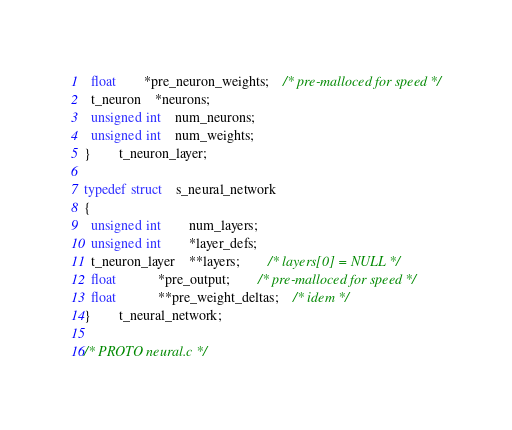Convert code to text. <code><loc_0><loc_0><loc_500><loc_500><_C_>  float		*pre_neuron_weights;	/* pre-malloced for speed */
  t_neuron	*neurons;
  unsigned int	num_neurons;
  unsigned int	num_weights;
}		t_neuron_layer;

typedef struct	s_neural_network
{
  unsigned int		num_layers;
  unsigned int		*layer_defs;
  t_neuron_layer	**layers;		/* layers[0] = NULL */
  float			*pre_output;		/* pre-malloced for speed */
  float			**pre_weight_deltas;	/* idem */
}		t_neural_network;

/* PROTO neural.c */</code> 